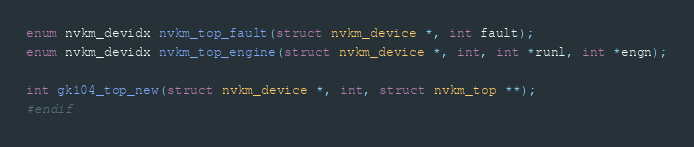Convert code to text. <code><loc_0><loc_0><loc_500><loc_500><_C_>enum nvkm_devidx nvkm_top_fault(struct nvkm_device *, int fault);
enum nvkm_devidx nvkm_top_engine(struct nvkm_device *, int, int *runl, int *engn);

int gk104_top_new(struct nvkm_device *, int, struct nvkm_top **);
#endif
</code> 